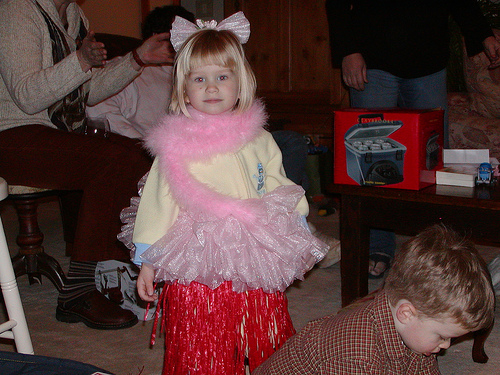<image>
Is the sandal to the right of the table leg? Yes. From this viewpoint, the sandal is positioned to the right side relative to the table leg. Is the girl in front of the boy? No. The girl is not in front of the boy. The spatial positioning shows a different relationship between these objects. 